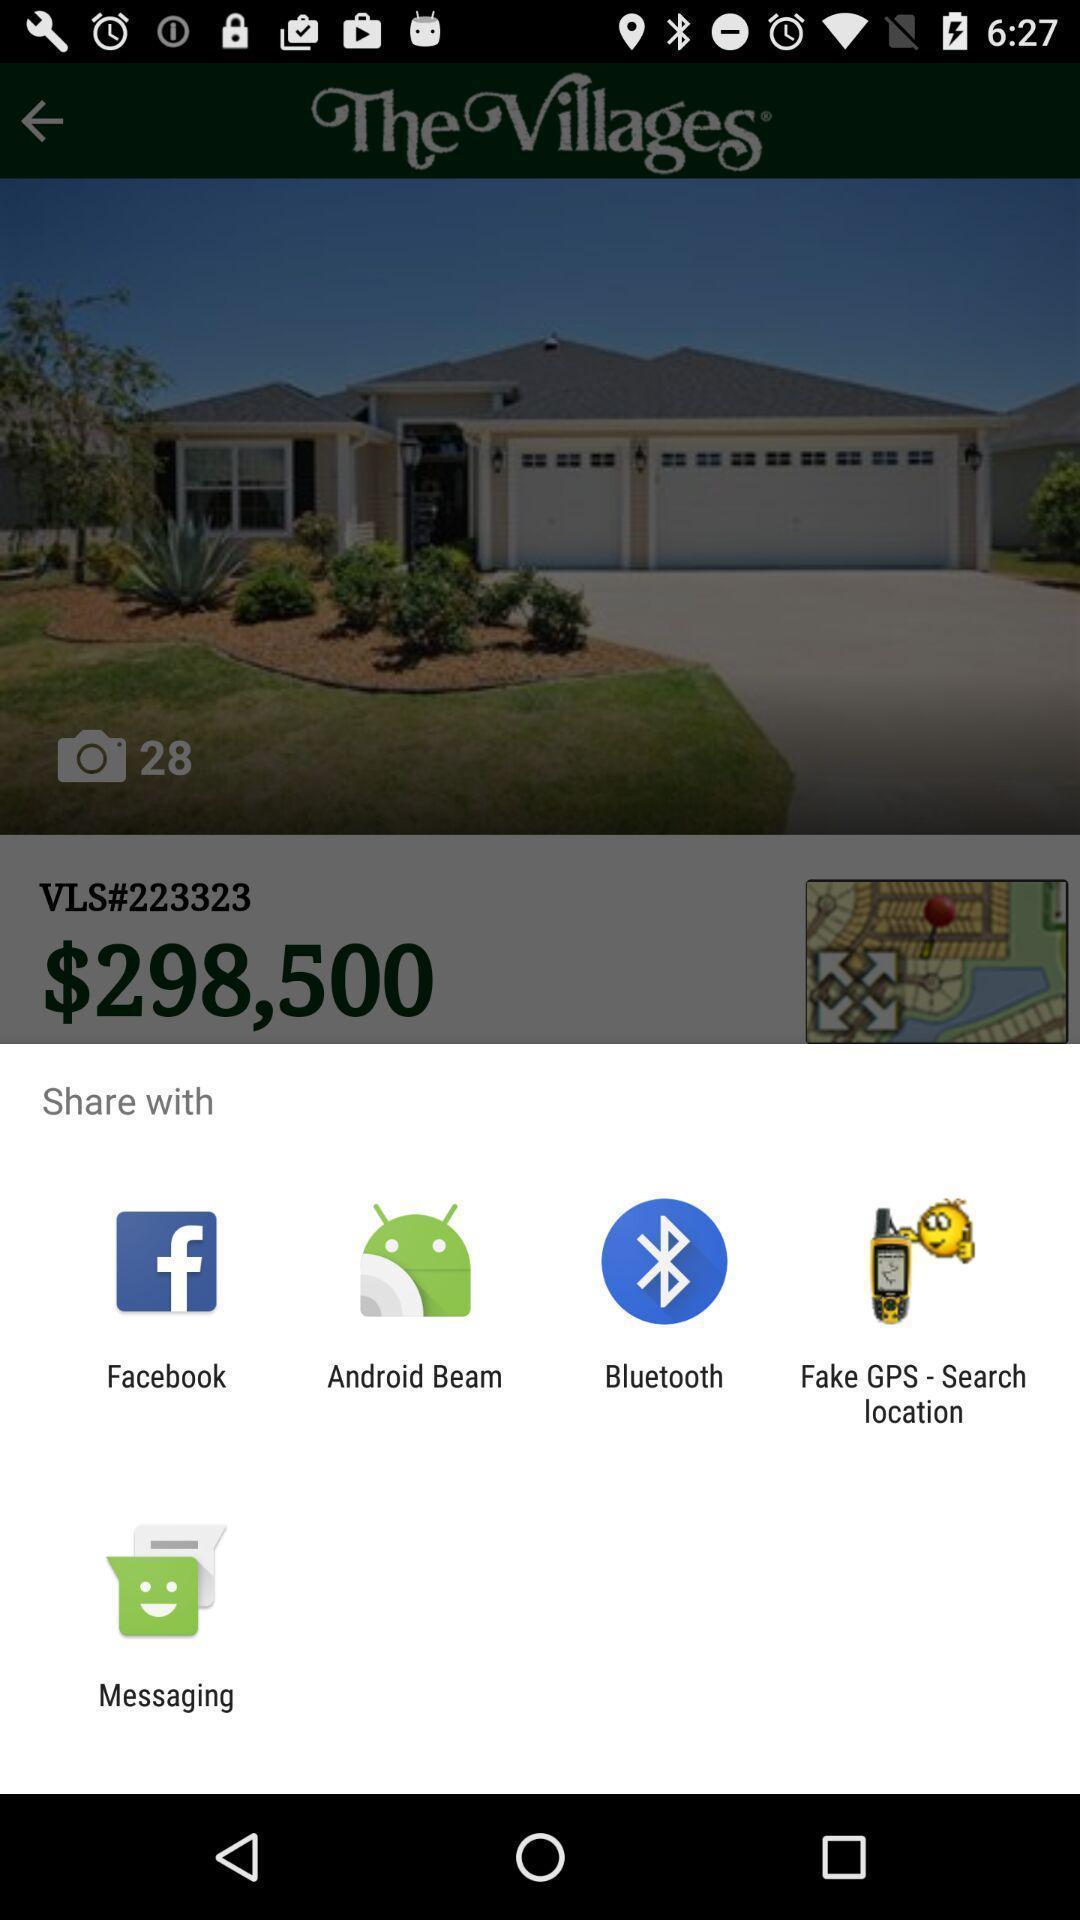Provide a detailed account of this screenshot. Pop up page displaying various apps to share info. 